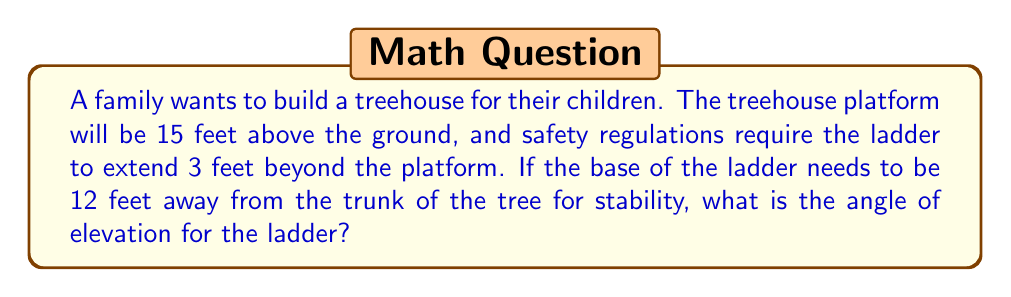What is the answer to this math problem? Let's approach this step-by-step:

1) First, we need to visualize the problem. The ladder forms the hypotenuse of a right triangle, where:
   - The vertical height is the height of the platform plus the extension (15 + 3 = 18 feet)
   - The horizontal distance is 12 feet

2) We can represent this situation with the following diagram:

[asy]
import geometry;

size(200);

pair A = (0,0), B = (12,0), C = (12,18);
draw(A--B--C--A);

label("Ground", (6,-1), S);
label("12 ft", (6,0), N);
label("18 ft", (13,9), E);
label("Ladder", (6,9), NW);
label("θ", (1,1), NW);

draw(rightanglemark(A,B,C,2));
[/asy]

3) We need to find the angle θ, which is the angle of elevation.

4) In a right triangle, we can use the tangent function to find this angle:

   $$\tan(\theta) = \frac{\text{opposite}}{\text{adjacent}} = \frac{\text{height}}{\text{base}}$$

5) Substituting our values:

   $$\tan(\theta) = \frac{18}{12} = \frac{3}{2} = 1.5$$

6) To find θ, we need to use the inverse tangent (arctan or $\tan^{-1}$):

   $$\theta = \tan^{-1}(1.5)$$

7) Using a calculator or computer, we can evaluate this:

   $$\theta \approx 56.31^\circ$$

Therefore, the angle of elevation for the ladder is approximately 56.31°.
Answer: The angle of elevation for the treehouse ladder is approximately 56.31°. 